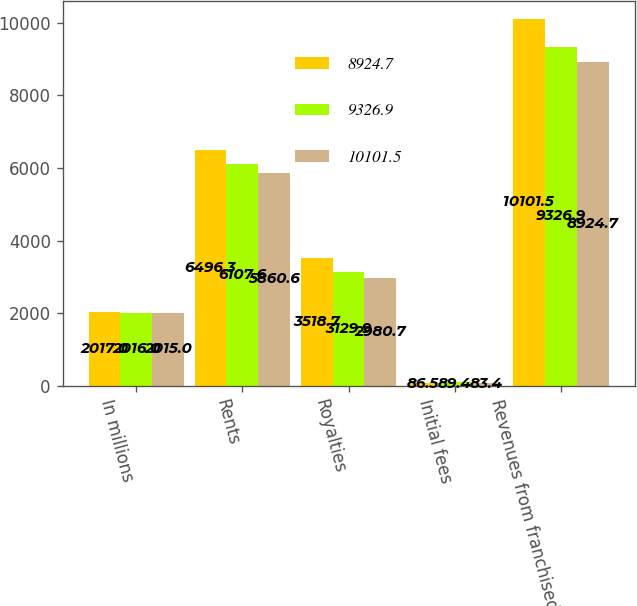Convert chart to OTSL. <chart><loc_0><loc_0><loc_500><loc_500><stacked_bar_chart><ecel><fcel>In millions<fcel>Rents<fcel>Royalties<fcel>Initial fees<fcel>Revenues from franchised<nl><fcel>8924.7<fcel>2017<fcel>6496.3<fcel>3518.7<fcel>86.5<fcel>10101.5<nl><fcel>9326.9<fcel>2016<fcel>6107.6<fcel>3129.9<fcel>89.4<fcel>9326.9<nl><fcel>10101.5<fcel>2015<fcel>5860.6<fcel>2980.7<fcel>83.4<fcel>8924.7<nl></chart> 